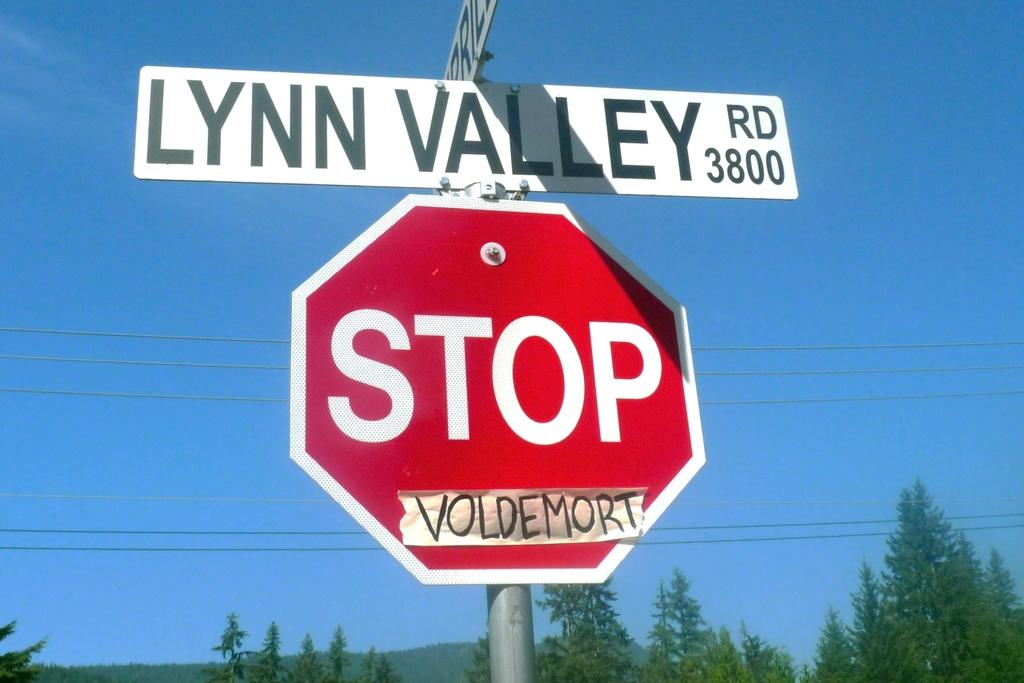<image>
Provide a brief description of the given image. A stop sign has the word VOLDEMORT on it. 